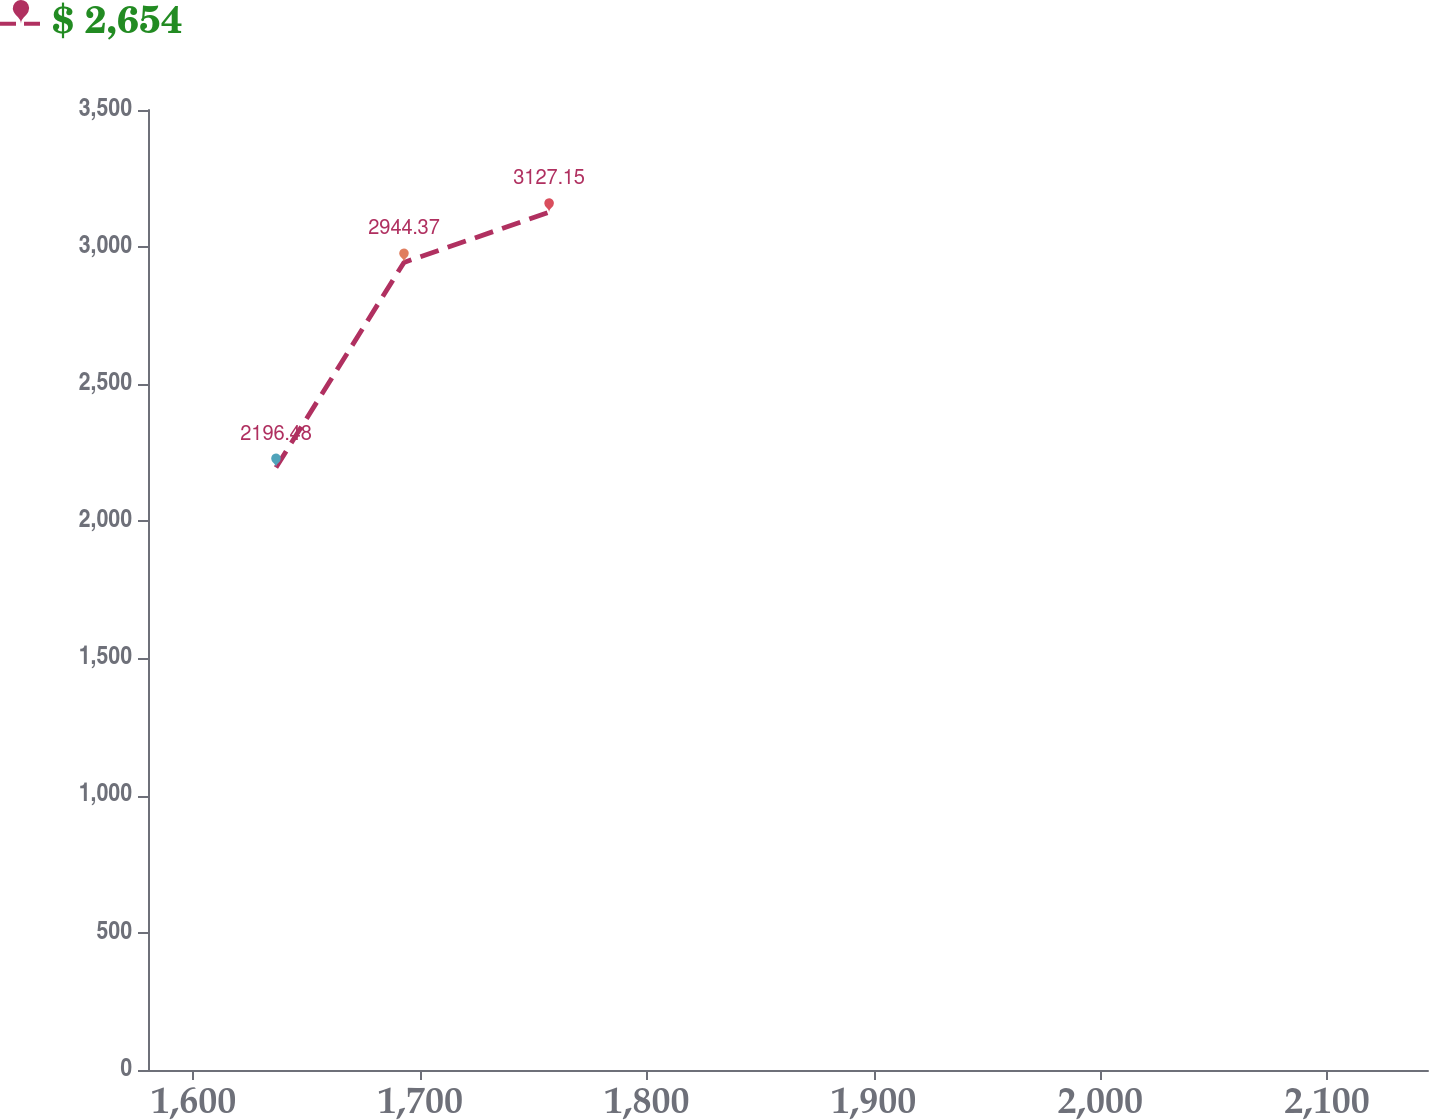Convert chart. <chart><loc_0><loc_0><loc_500><loc_500><line_chart><ecel><fcel>$ 2,654<nl><fcel>1636.42<fcel>2196.48<nl><fcel>1692.88<fcel>2944.37<nl><fcel>1756.89<fcel>3127.15<nl><fcel>2201.04<fcel>2761.72<nl></chart> 